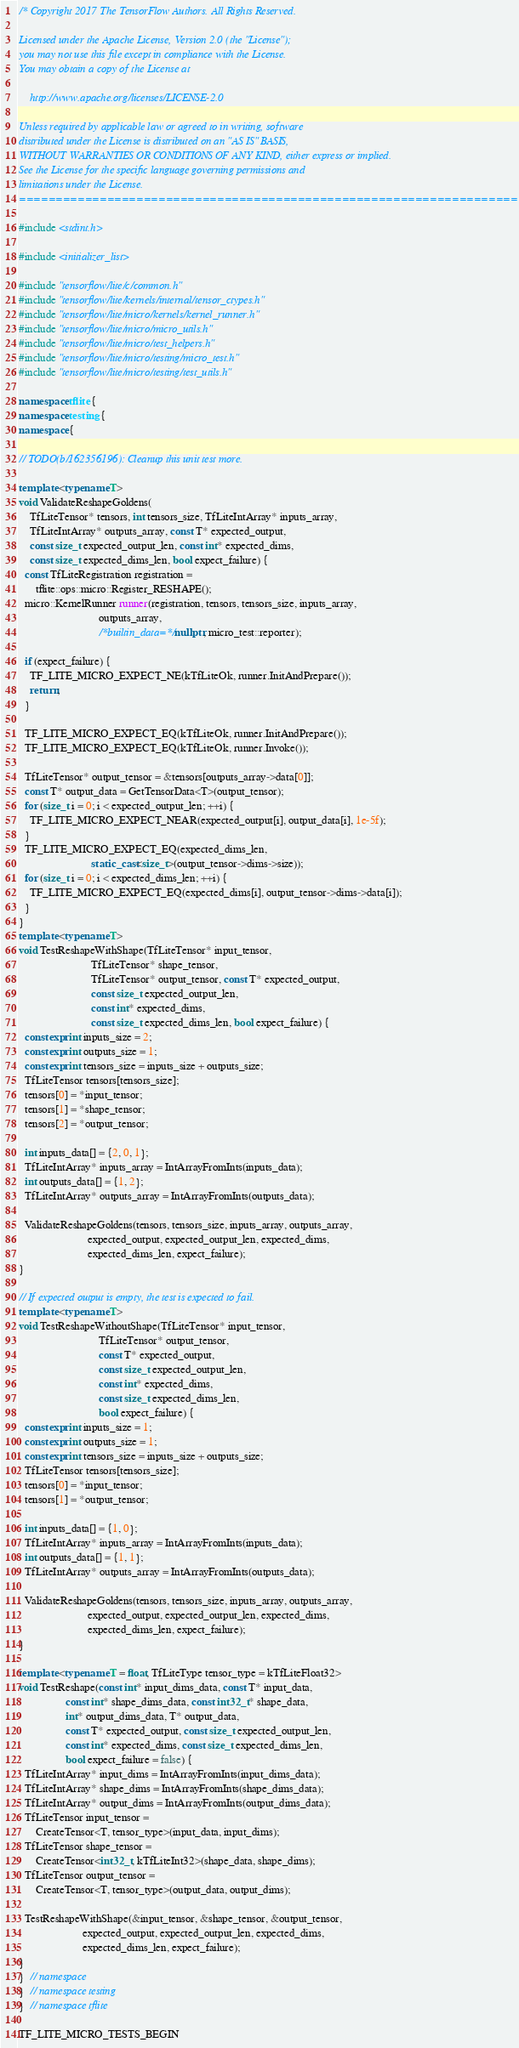Convert code to text. <code><loc_0><loc_0><loc_500><loc_500><_C++_>/* Copyright 2017 The TensorFlow Authors. All Rights Reserved.

Licensed under the Apache License, Version 2.0 (the "License");
you may not use this file except in compliance with the License.
You may obtain a copy of the License at

    http://www.apache.org/licenses/LICENSE-2.0

Unless required by applicable law or agreed to in writing, software
distributed under the License is distributed on an "AS IS" BASIS,
WITHOUT WARRANTIES OR CONDITIONS OF ANY KIND, either express or implied.
See the License for the specific language governing permissions and
limitations under the License.
==============================================================================*/

#include <stdint.h>

#include <initializer_list>

#include "tensorflow/lite/c/common.h"
#include "tensorflow/lite/kernels/internal/tensor_ctypes.h"
#include "tensorflow/lite/micro/kernels/kernel_runner.h"
#include "tensorflow/lite/micro/micro_utils.h"
#include "tensorflow/lite/micro/test_helpers.h"
#include "tensorflow/lite/micro/testing/micro_test.h"
#include "tensorflow/lite/micro/testing/test_utils.h"

namespace tflite {
namespace testing {
namespace {

// TODO(b/162356196): Cleanup this unit test more.

template <typename T>
void ValidateReshapeGoldens(
    TfLiteTensor* tensors, int tensors_size, TfLiteIntArray* inputs_array,
    TfLiteIntArray* outputs_array, const T* expected_output,
    const size_t expected_output_len, const int* expected_dims,
    const size_t expected_dims_len, bool expect_failure) {
  const TfLiteRegistration registration =
      tflite::ops::micro::Register_RESHAPE();
  micro::KernelRunner runner(registration, tensors, tensors_size, inputs_array,
                             outputs_array,
                             /*builtin_data=*/nullptr, micro_test::reporter);

  if (expect_failure) {
    TF_LITE_MICRO_EXPECT_NE(kTfLiteOk, runner.InitAndPrepare());
    return;
  }

  TF_LITE_MICRO_EXPECT_EQ(kTfLiteOk, runner.InitAndPrepare());
  TF_LITE_MICRO_EXPECT_EQ(kTfLiteOk, runner.Invoke());

  TfLiteTensor* output_tensor = &tensors[outputs_array->data[0]];
  const T* output_data = GetTensorData<T>(output_tensor);
  for (size_t i = 0; i < expected_output_len; ++i) {
    TF_LITE_MICRO_EXPECT_NEAR(expected_output[i], output_data[i], 1e-5f);
  }
  TF_LITE_MICRO_EXPECT_EQ(expected_dims_len,
                          static_cast<size_t>(output_tensor->dims->size));
  for (size_t i = 0; i < expected_dims_len; ++i) {
    TF_LITE_MICRO_EXPECT_EQ(expected_dims[i], output_tensor->dims->data[i]);
  }
}
template <typename T>
void TestReshapeWithShape(TfLiteTensor* input_tensor,
                          TfLiteTensor* shape_tensor,
                          TfLiteTensor* output_tensor, const T* expected_output,
                          const size_t expected_output_len,
                          const int* expected_dims,
                          const size_t expected_dims_len, bool expect_failure) {
  constexpr int inputs_size = 2;
  constexpr int outputs_size = 1;
  constexpr int tensors_size = inputs_size + outputs_size;
  TfLiteTensor tensors[tensors_size];
  tensors[0] = *input_tensor;
  tensors[1] = *shape_tensor;
  tensors[2] = *output_tensor;

  int inputs_data[] = {2, 0, 1};
  TfLiteIntArray* inputs_array = IntArrayFromInts(inputs_data);
  int outputs_data[] = {1, 2};
  TfLiteIntArray* outputs_array = IntArrayFromInts(outputs_data);

  ValidateReshapeGoldens(tensors, tensors_size, inputs_array, outputs_array,
                         expected_output, expected_output_len, expected_dims,
                         expected_dims_len, expect_failure);
}

// If expected output is empty, the test is expected to fail.
template <typename T>
void TestReshapeWithoutShape(TfLiteTensor* input_tensor,
                             TfLiteTensor* output_tensor,
                             const T* expected_output,
                             const size_t expected_output_len,
                             const int* expected_dims,
                             const size_t expected_dims_len,
                             bool expect_failure) {
  constexpr int inputs_size = 1;
  constexpr int outputs_size = 1;
  constexpr int tensors_size = inputs_size + outputs_size;
  TfLiteTensor tensors[tensors_size];
  tensors[0] = *input_tensor;
  tensors[1] = *output_tensor;

  int inputs_data[] = {1, 0};
  TfLiteIntArray* inputs_array = IntArrayFromInts(inputs_data);
  int outputs_data[] = {1, 1};
  TfLiteIntArray* outputs_array = IntArrayFromInts(outputs_data);

  ValidateReshapeGoldens(tensors, tensors_size, inputs_array, outputs_array,
                         expected_output, expected_output_len, expected_dims,
                         expected_dims_len, expect_failure);
}

template <typename T = float, TfLiteType tensor_type = kTfLiteFloat32>
void TestReshape(const int* input_dims_data, const T* input_data,
                 const int* shape_dims_data, const int32_t* shape_data,
                 int* output_dims_data, T* output_data,
                 const T* expected_output, const size_t expected_output_len,
                 const int* expected_dims, const size_t expected_dims_len,
                 bool expect_failure = false) {
  TfLiteIntArray* input_dims = IntArrayFromInts(input_dims_data);
  TfLiteIntArray* shape_dims = IntArrayFromInts(shape_dims_data);
  TfLiteIntArray* output_dims = IntArrayFromInts(output_dims_data);
  TfLiteTensor input_tensor =
      CreateTensor<T, tensor_type>(input_data, input_dims);
  TfLiteTensor shape_tensor =
      CreateTensor<int32_t, kTfLiteInt32>(shape_data, shape_dims);
  TfLiteTensor output_tensor =
      CreateTensor<T, tensor_type>(output_data, output_dims);

  TestReshapeWithShape(&input_tensor, &shape_tensor, &output_tensor,
                       expected_output, expected_output_len, expected_dims,
                       expected_dims_len, expect_failure);
}
}  // namespace
}  // namespace testing
}  // namespace tflite

TF_LITE_MICRO_TESTS_BEGIN
</code> 